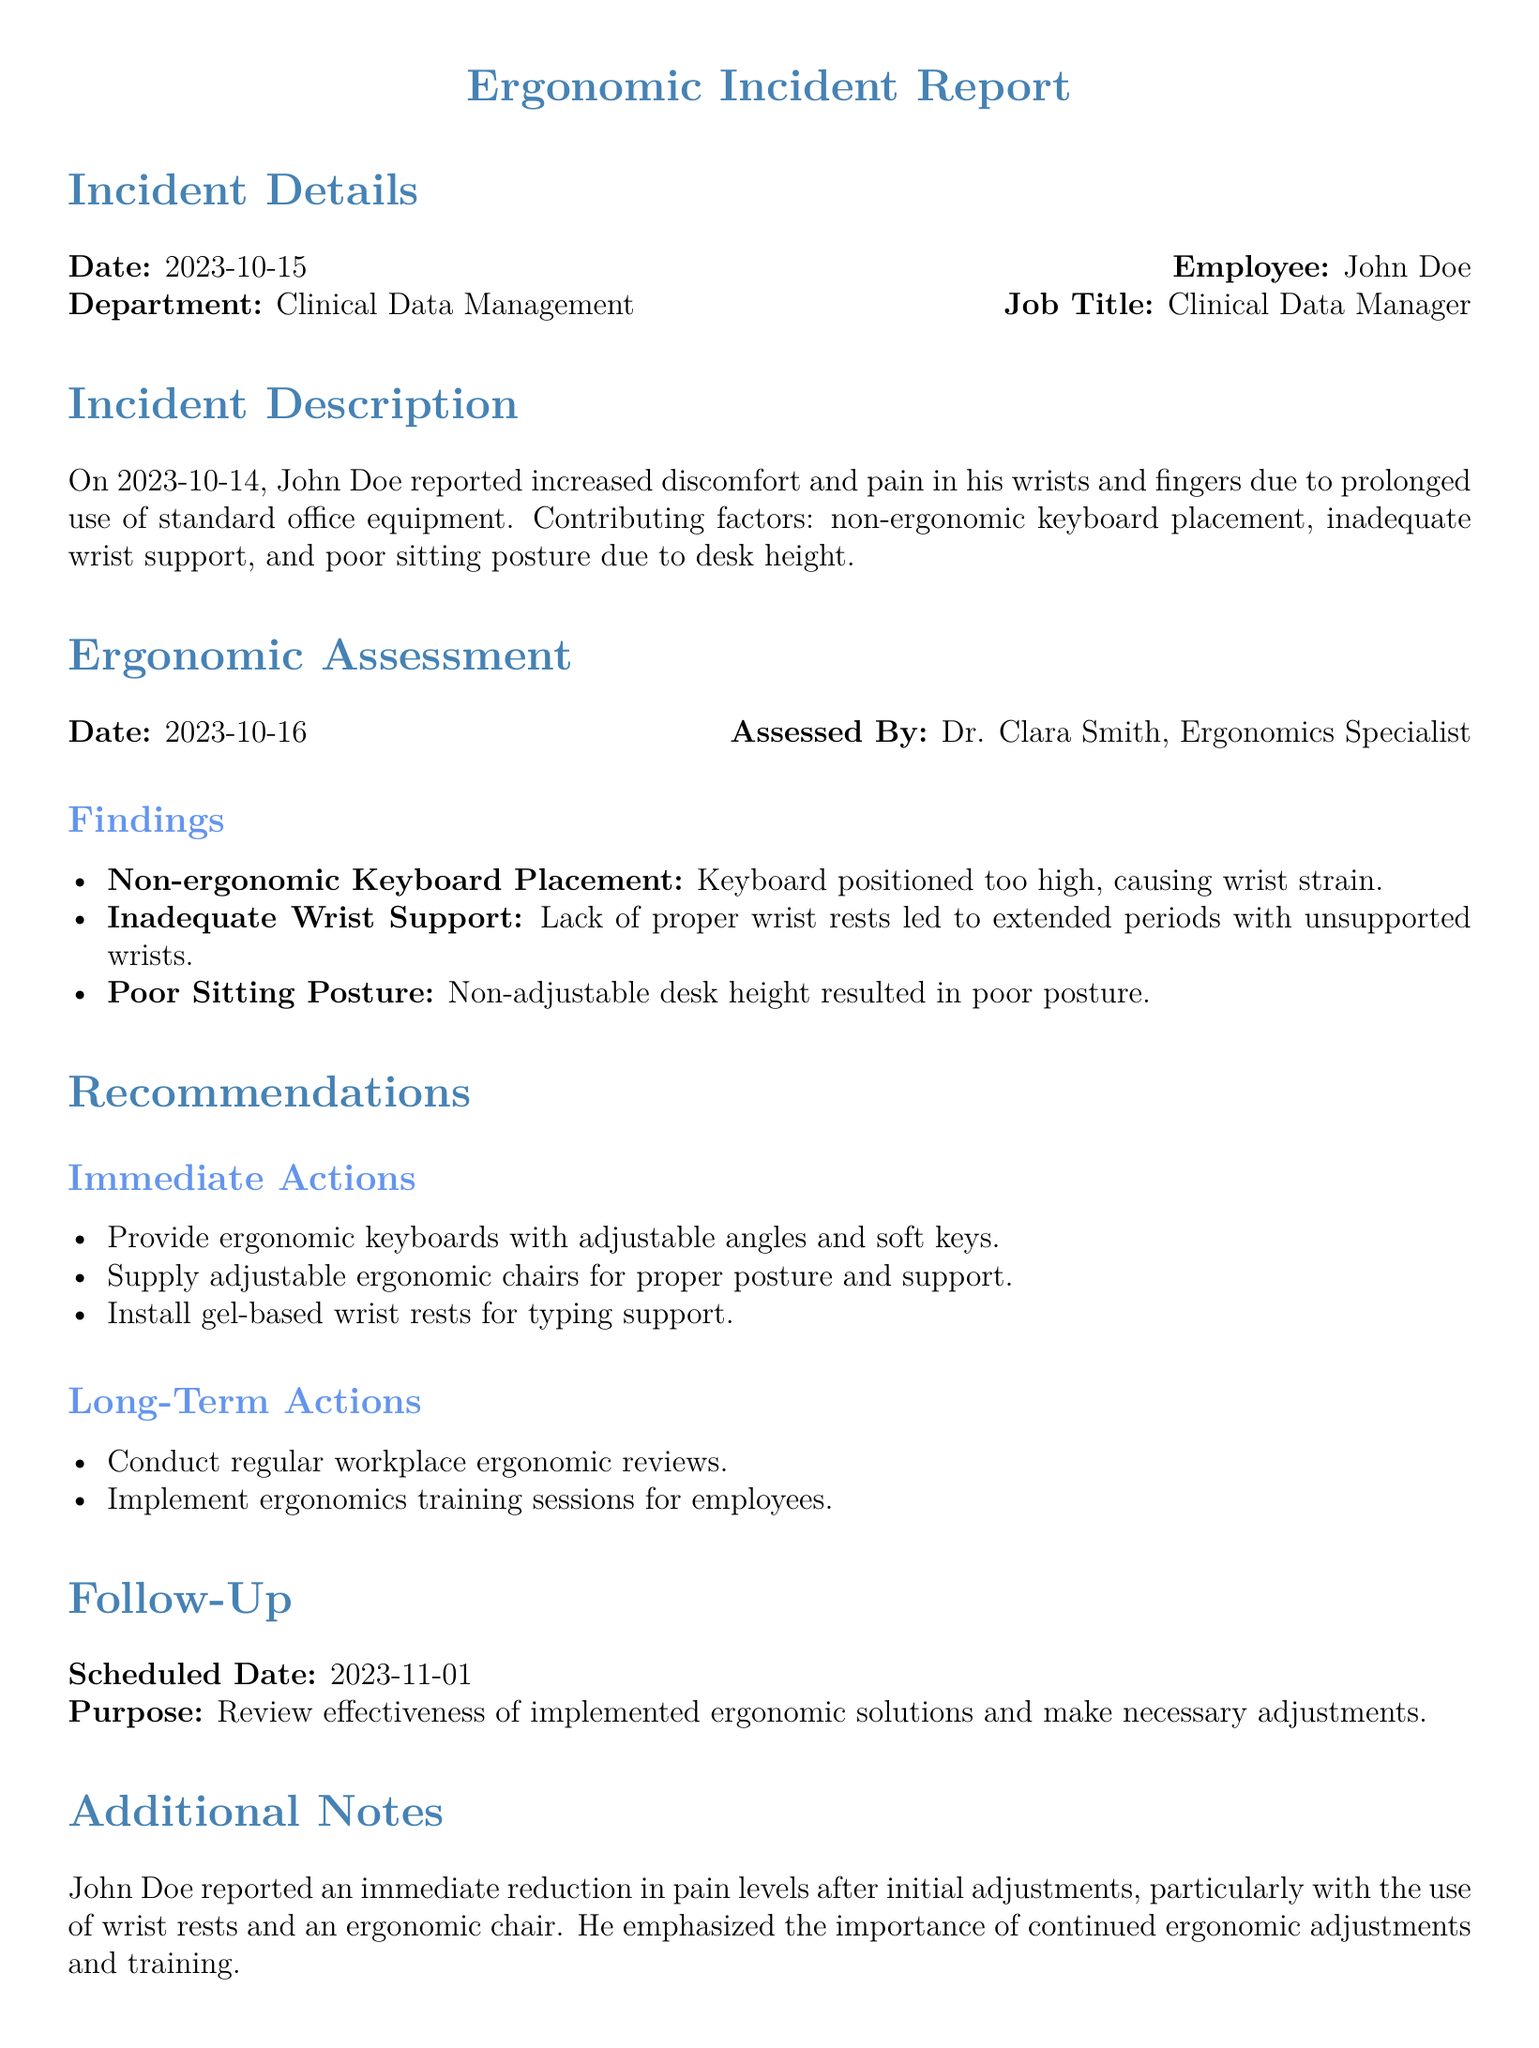What is the date of the incident report? The date is explicitly stated at the beginning of the document as 2023-10-15.
Answer: 2023-10-15 Who assessed the ergonomic situation? The report mentions that the assessment was conducted by Dr. Clara Smith, Ergonomics Specialist.
Answer: Dr. Clara Smith What department does John Doe work in? The document clearly states that John Doe is part of the Clinical Data Management department.
Answer: Clinical Data Management What immediate action is recommended for wrist support? The report specifies the installation of gel-based wrist rests for typing support as an immediate action.
Answer: Gel-based wrist rests What is the scheduled follow-up date? The document indicates that the follow-up date is set for 2023-11-01.
Answer: 2023-11-01 What was the main cause of discomfort reported by John Doe? The main cause of discomfort is attributed to prolonged use of standard office equipment.
Answer: Prolonged use of standard office equipment What long-term action is suggested for a better ergonomic environment? The report recommends conducting regular workplace ergonomic reviews as a long-term action.
Answer: Conduct regular workplace ergonomic reviews What aspect of the workplace setup contributed to poor posture? The document mentions that non-adjustable desk height contributed to poor posture for John Doe.
Answer: Non-adjustable desk height What tool was provided to offer support for typing? The report recommends providing ergonomic keyboards with adjustable angles and soft keys.
Answer: Ergonomic keyboards 